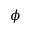Convert formula to latex. <formula><loc_0><loc_0><loc_500><loc_500>\phi</formula> 